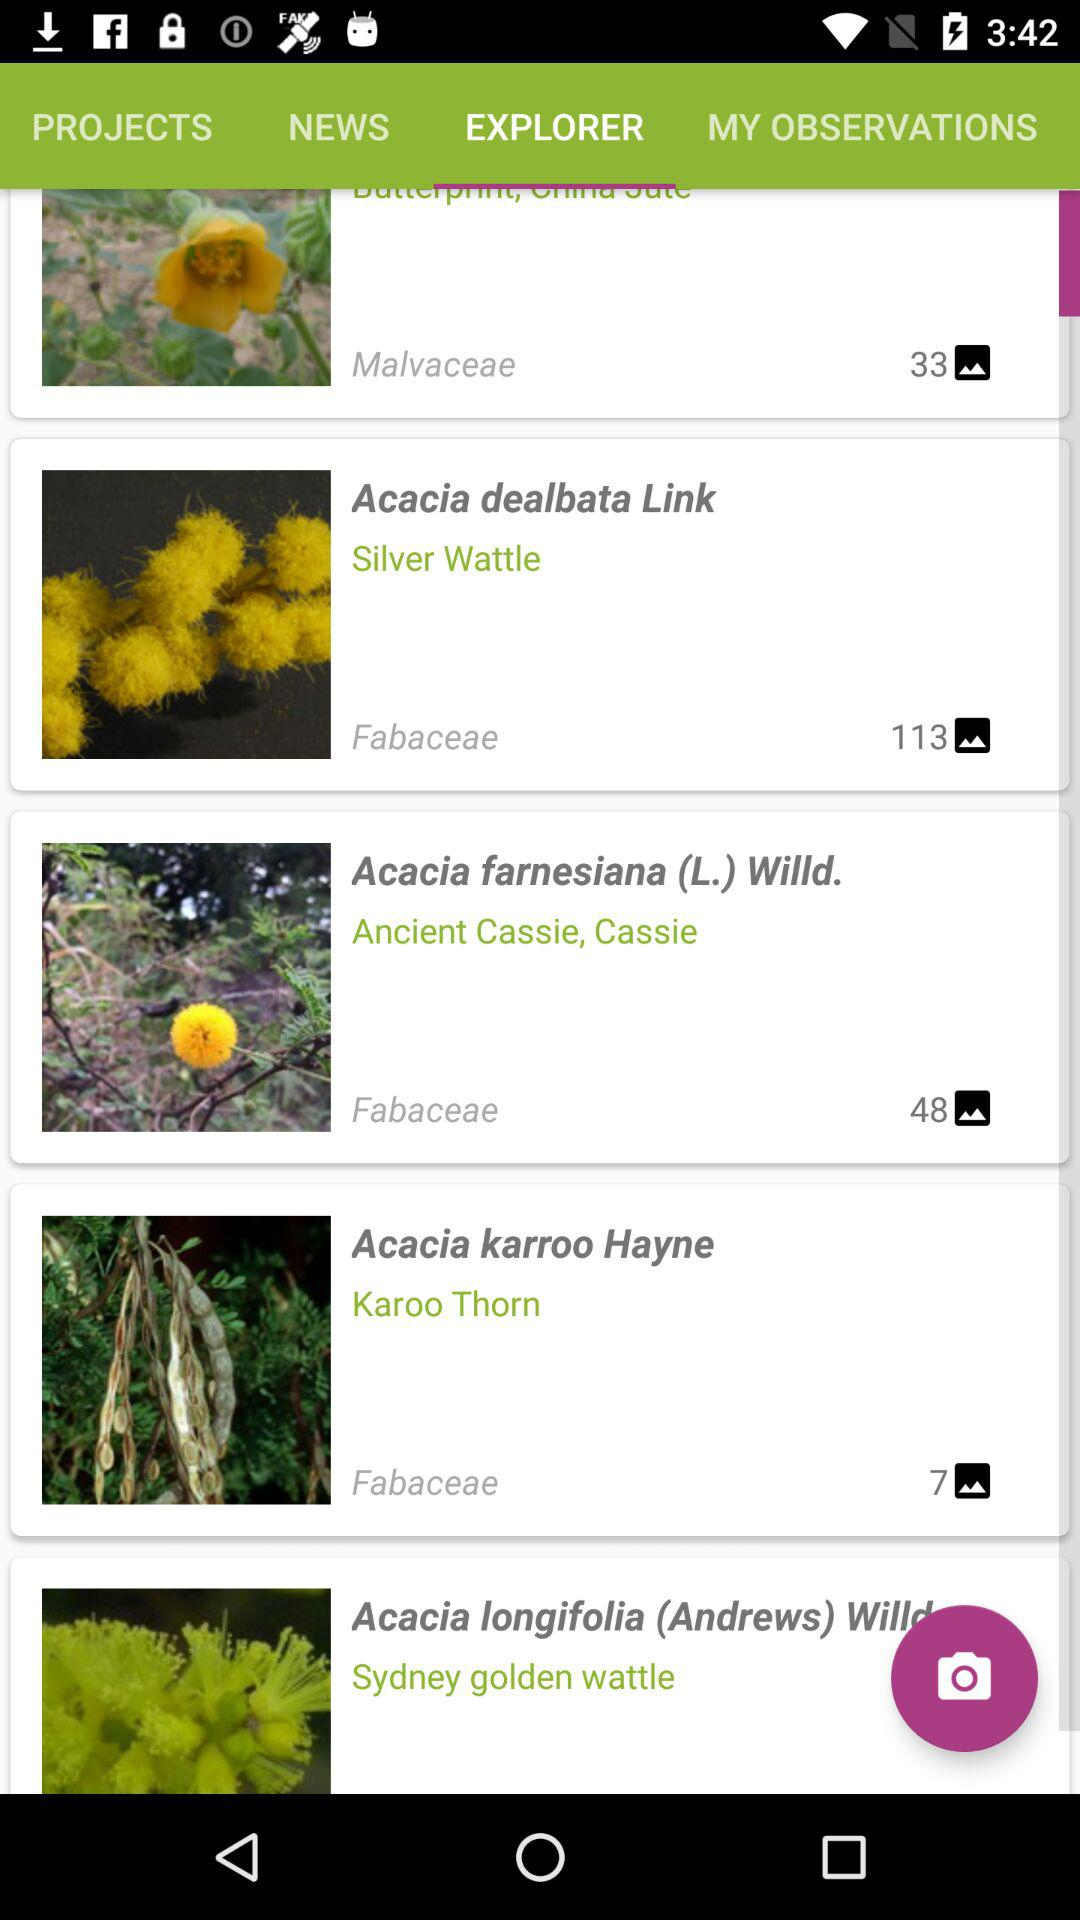What folder has 48 images in total? The folder is "Acacia farnesiana (L.) Willd.". 